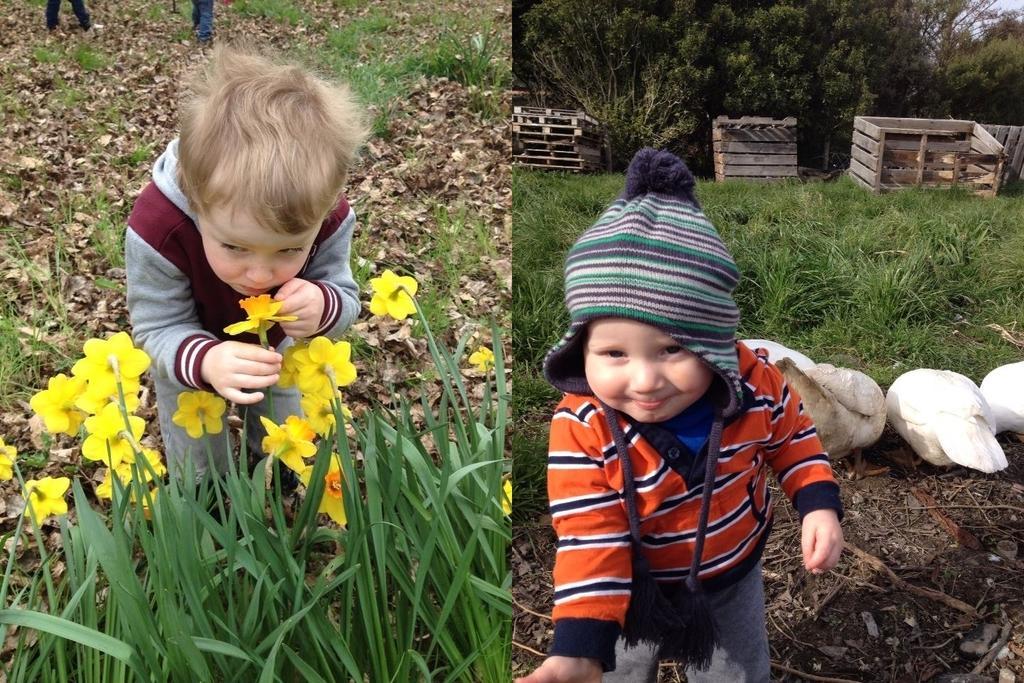In one or two sentences, can you explain what this image depicts? This is a collage in this image on the right side there is one boy who is wearing a hat, and there are birds grass, wooden boxes and some trees. On the left side there is one boy who is holding some flowers, and there are some flowers and plants. And in the background there are some dry leaves, and grass and some persons. 